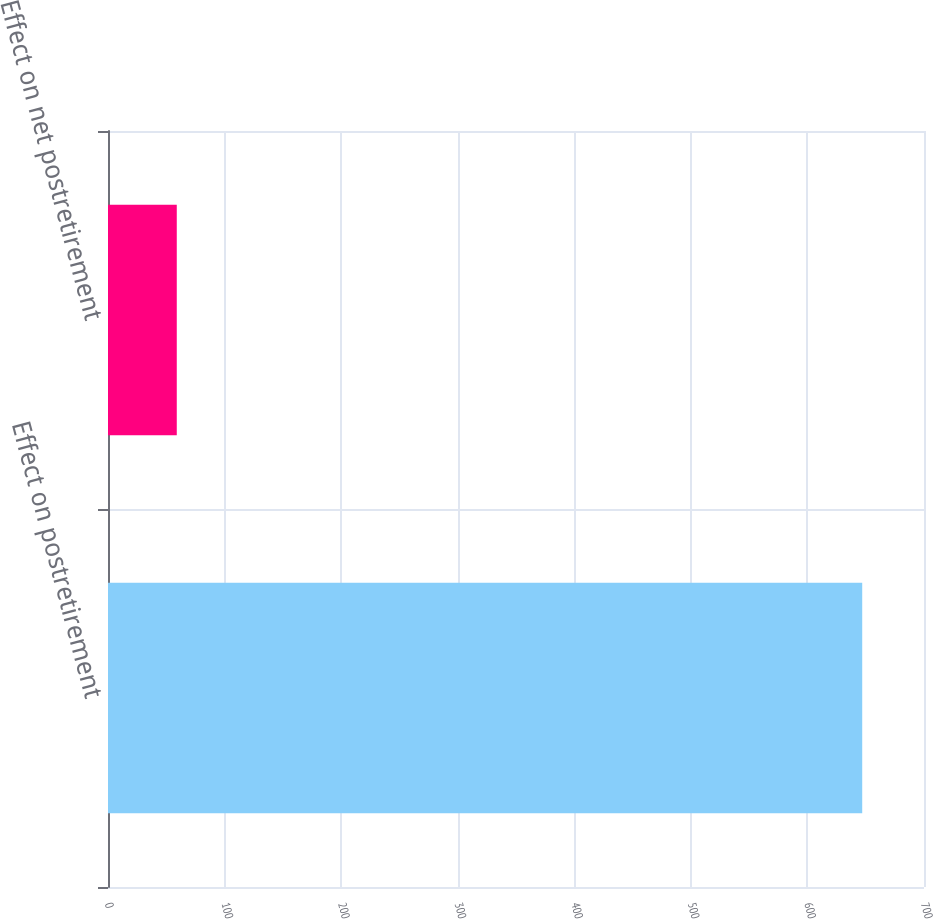Convert chart to OTSL. <chart><loc_0><loc_0><loc_500><loc_500><bar_chart><fcel>Effect on postretirement<fcel>Effect on net postretirement<nl><fcel>647<fcel>59<nl></chart> 